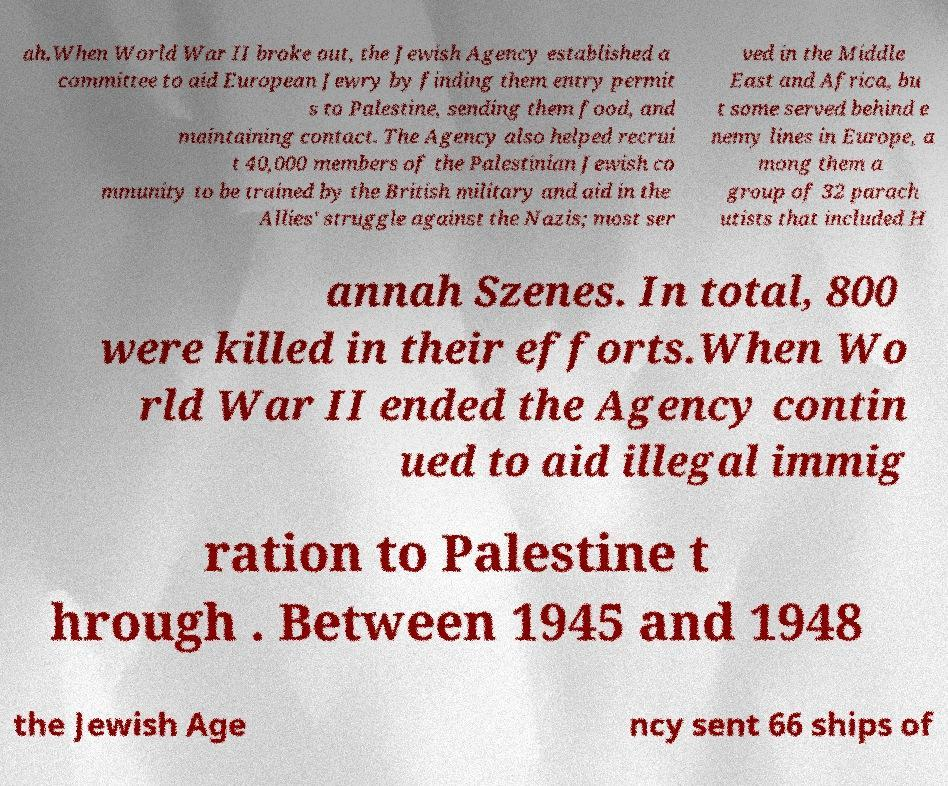Can you accurately transcribe the text from the provided image for me? ah.When World War II broke out, the Jewish Agency established a committee to aid European Jewry by finding them entry permit s to Palestine, sending them food, and maintaining contact. The Agency also helped recrui t 40,000 members of the Palestinian Jewish co mmunity to be trained by the British military and aid in the Allies' struggle against the Nazis; most ser ved in the Middle East and Africa, bu t some served behind e nemy lines in Europe, a mong them a group of 32 parach utists that included H annah Szenes. In total, 800 were killed in their efforts.When Wo rld War II ended the Agency contin ued to aid illegal immig ration to Palestine t hrough . Between 1945 and 1948 the Jewish Age ncy sent 66 ships of 